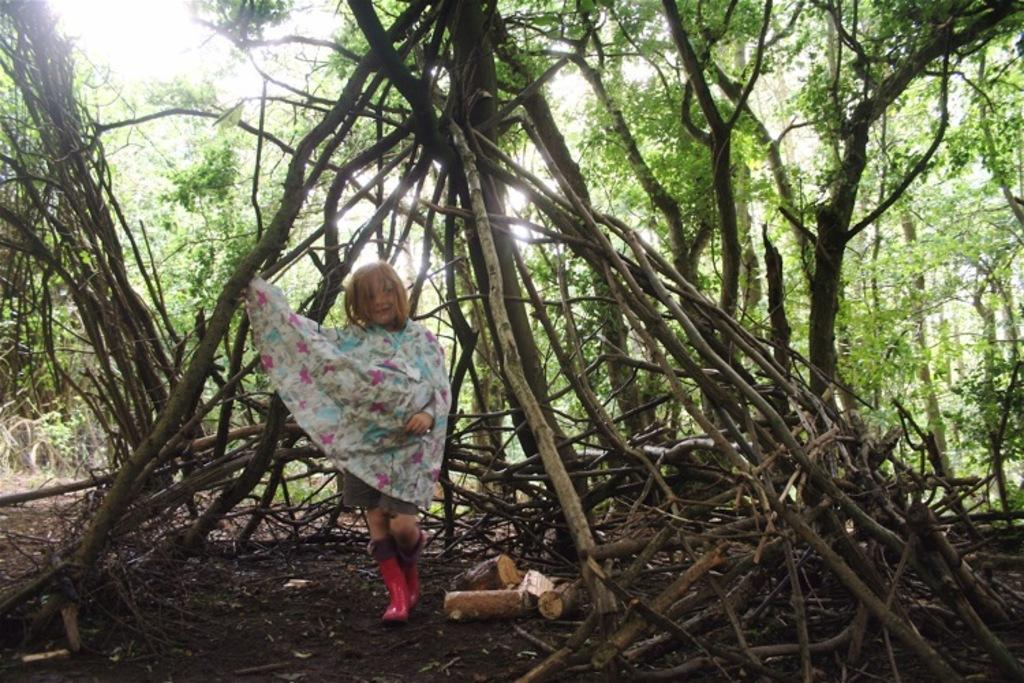What is located in the foreground of the image? There are wooden logs and soil in the foreground of the image. Who or what else can be seen in the foreground of the image? There is a girl in the foreground of the image. What can be seen in the background of the image? There are trees in the background of the image. What type of thrill can be seen in the image? There is no specific thrill depicted in the image; it features wooden logs, soil, and a girl in the foreground, and trees in the background. How many steps are visible in the image? There is no mention of steps in the image; it only includes wooden logs, soil, a girl, and trees. 